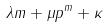<formula> <loc_0><loc_0><loc_500><loc_500>\lambda m + \mu p ^ { m } + \kappa</formula> 